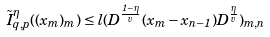<formula> <loc_0><loc_0><loc_500><loc_500>\tilde { I } _ { q , p } ^ { \eta } ( ( x _ { m } ) _ { m } ) \leq l ( D ^ { \frac { 1 - \eta } { v } } ( x _ { m } - x _ { n - 1 } ) D ^ { \frac { \eta } { v } } ) _ { m , n }</formula> 